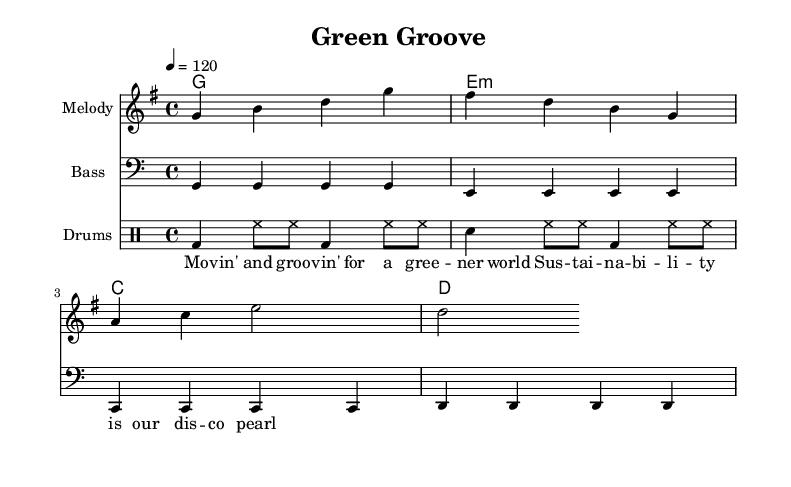What is the key signature of this music? The key signature is G major, which contains one sharp (F#). This is determined by the presence of the key signature notated at the beginning of the score.
Answer: G major What is the time signature of the piece? The time signature is 4/4, which indicates four beats per measure and is the most common time signature in disco music. This can be identified from the notation at the beginning of the score.
Answer: 4/4 What is the tempo marking for the music? The tempo marking is 120 beats per minute, indicated in the score by the tempo directive provided above the staff. This indicates how fast the music should be played.
Answer: 120 How many measures are in the melody section? The melody section contains four measures, identifiable by counting the vertical bar lines that separate the measures in the staff.
Answer: 4 What instrument is the bass line written for? The bass line is written for bass, which is indicated by the "Bass" label on the staff and the use of the bass clef. This provides context for the specific range and function of the notes.
Answer: Bass What is the lyrical theme expressed in this piece? The lyrics express a theme of sustainability and environmental responsibility, as seen in the phrases like "groovin' for a greener world" and "sustainability is our disco pearl." This captures the essence of the song's message.
Answer: Sustainability 